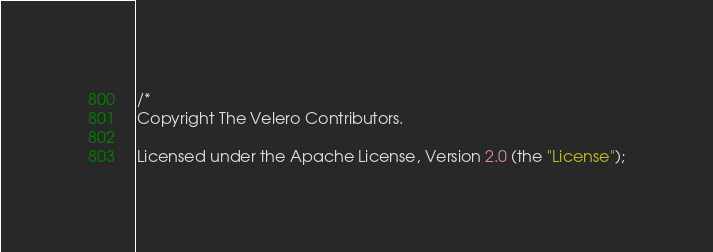Convert code to text. <code><loc_0><loc_0><loc_500><loc_500><_Go_>/*
Copyright The Velero Contributors.

Licensed under the Apache License, Version 2.0 (the "License");</code> 